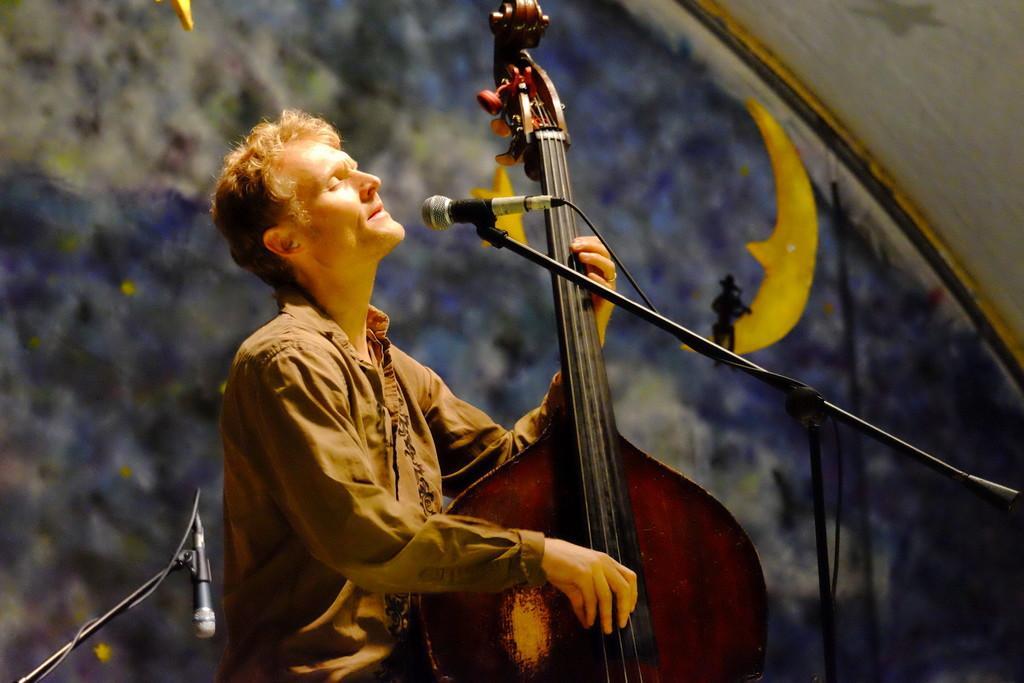Could you give a brief overview of what you see in this image? In this image I see a man who is holding a musical instrument and he is in front of a mic, I can also see another mic over here. 